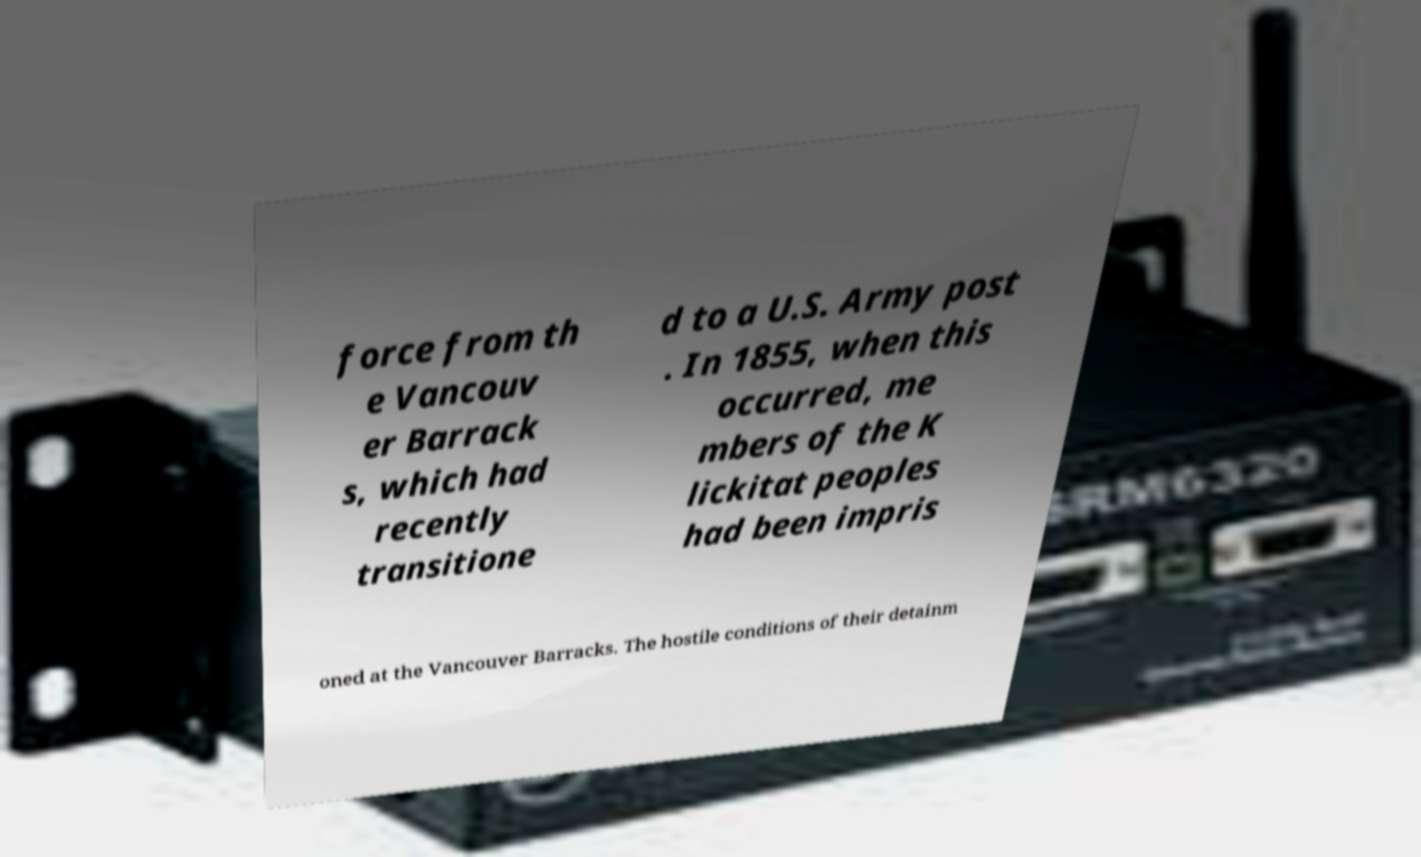Please identify and transcribe the text found in this image. force from th e Vancouv er Barrack s, which had recently transitione d to a U.S. Army post . In 1855, when this occurred, me mbers of the K lickitat peoples had been impris oned at the Vancouver Barracks. The hostile conditions of their detainm 